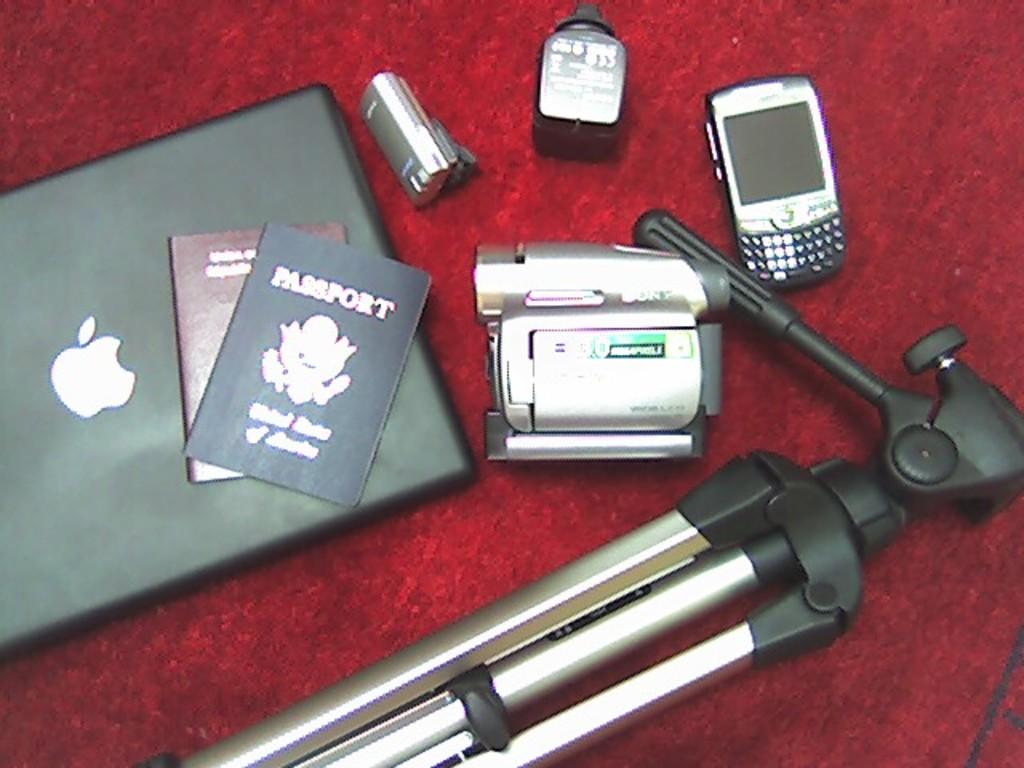Who made the camera?
Provide a short and direct response. Sony. What kind of federal document is shown?
Keep it short and to the point. Passport. 